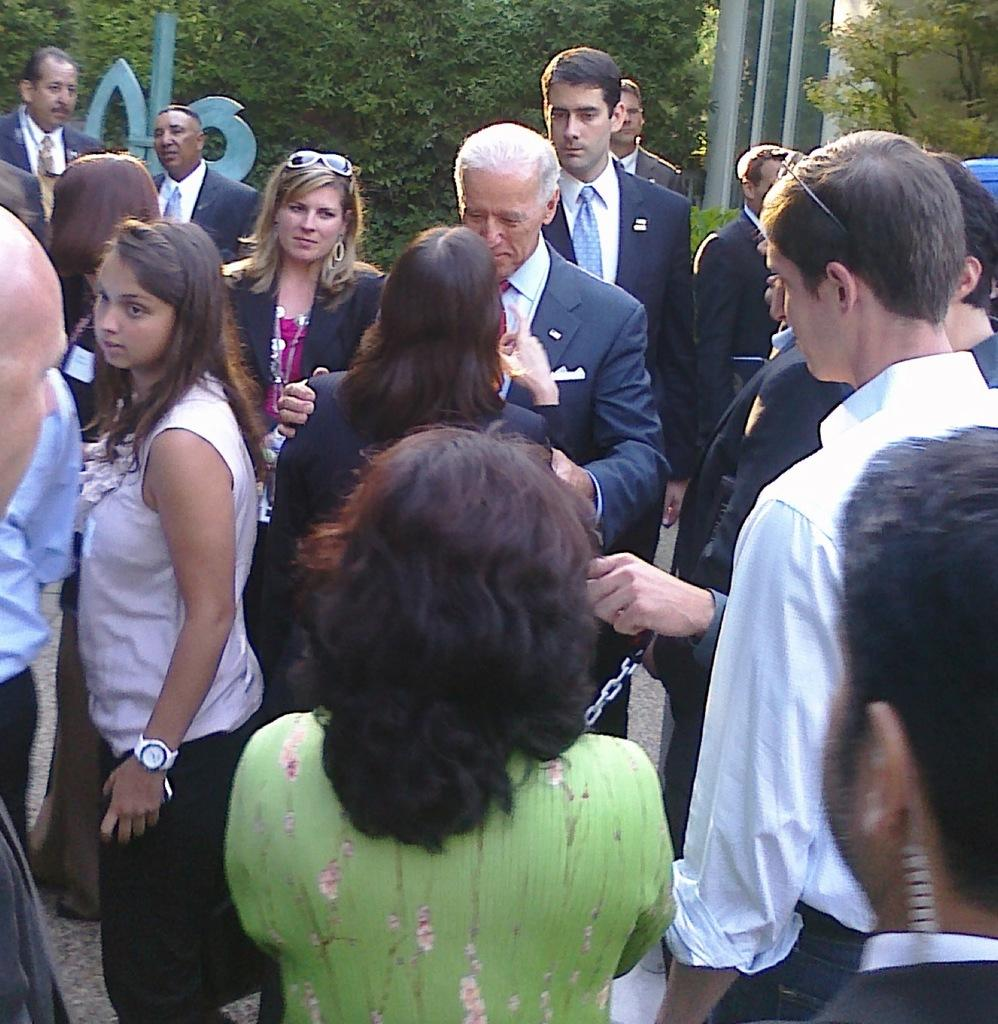What is the main feature of the image? There is a road in the image. Are there any people visible in the image? Yes, there are people standing in the image. What can be seen in the distance in the image? There are trees and a blue color object in the background of the image. Is there a fight happening between the trees in the background of the image? No, there is no fight happening between the trees in the background of the image. 